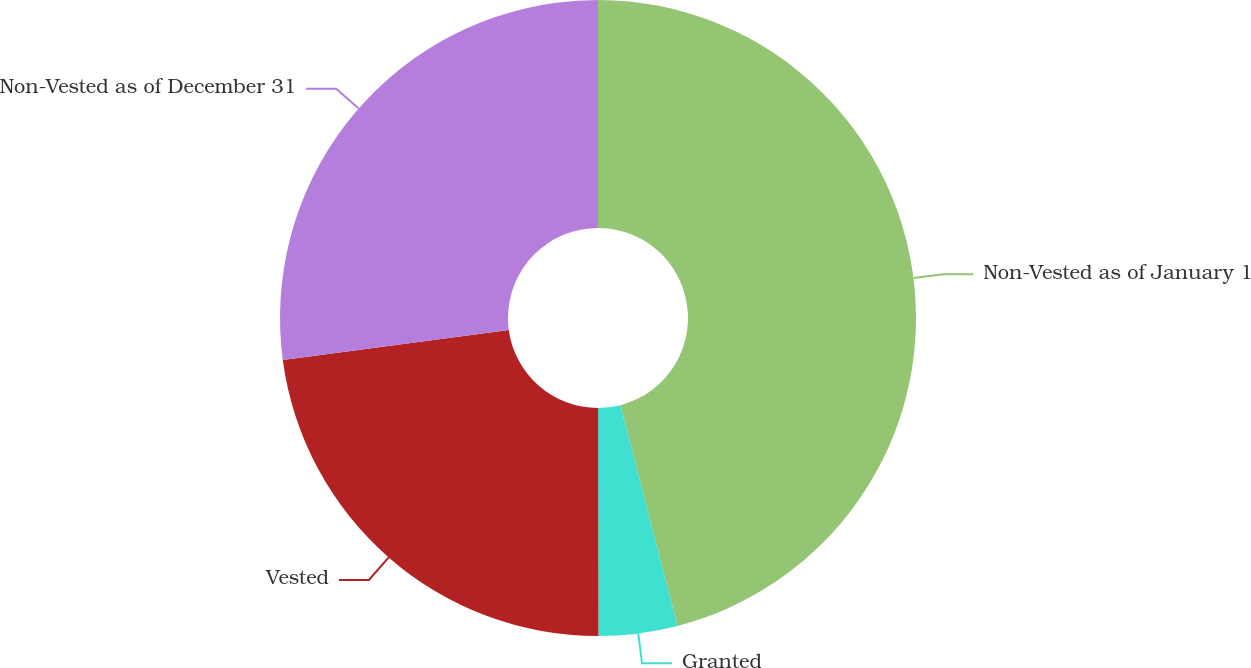Convert chart. <chart><loc_0><loc_0><loc_500><loc_500><pie_chart><fcel>Non-Vested as of January 1<fcel>Granted<fcel>Vested<fcel>Non-Vested as of December 31<nl><fcel>45.98%<fcel>4.0%<fcel>22.91%<fcel>27.11%<nl></chart> 